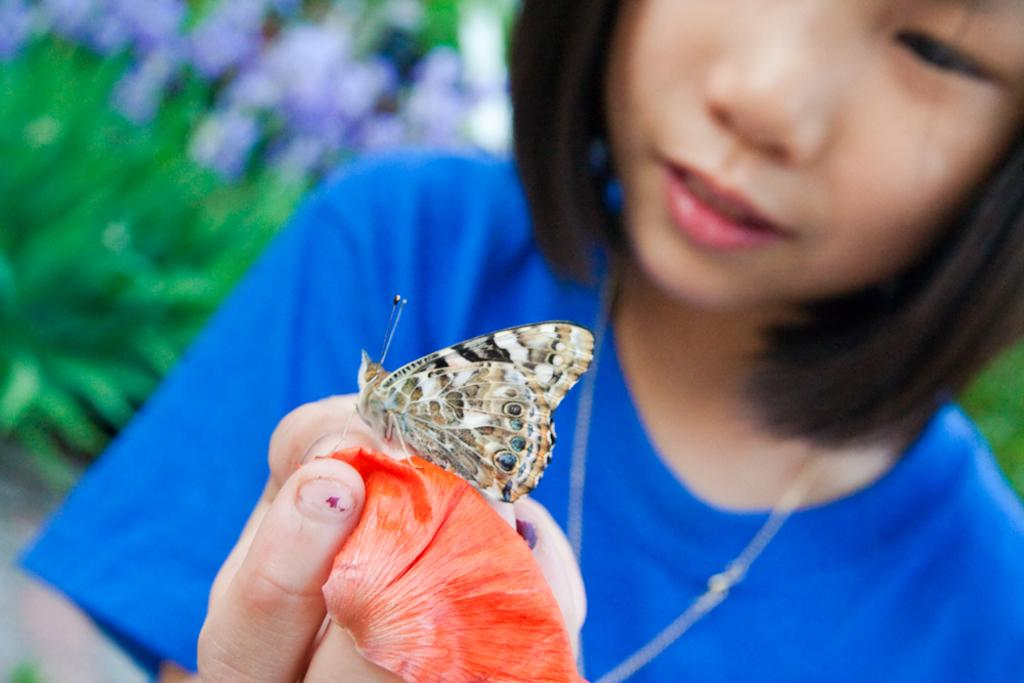Who is the main subject in the image? There is a girl in the image. What is the girl holding in her hand? The girl is holding something in her hand, but the specific object is not mentioned in the facts. Can you describe the butterfly in the image? There is a butterfly on the object the girl is holding. What is the color or appearance of the background in the image? The background of the image is green and blurred. What is the girl's tendency towards farming in the image? There is no information about the girl's tendency towards farming in the image. 